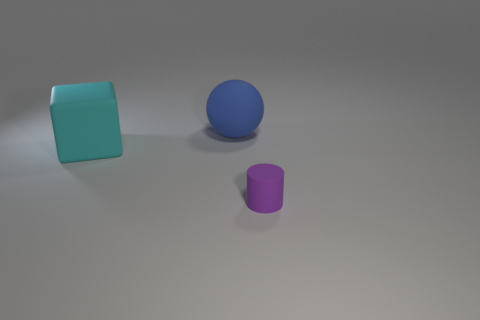Is there anything else that is the same size as the matte cylinder?
Make the answer very short. No. What number of things are either large cyan rubber things or small brown metallic cylinders?
Offer a terse response. 1. Are there the same number of objects that are to the left of the large cyan rubber object and tiny red rubber balls?
Your response must be concise. Yes. There is a rubber thing in front of the object that is to the left of the blue object; is there a cyan thing behind it?
Offer a terse response. Yes. The large sphere that is made of the same material as the purple cylinder is what color?
Ensure brevity in your answer.  Blue. What number of blocks are either small rubber things or large blue things?
Provide a succinct answer. 0. What is the size of the thing that is behind the matte thing to the left of the rubber object that is behind the rubber block?
Ensure brevity in your answer.  Large. What shape is the matte thing that is the same size as the rubber block?
Your answer should be very brief. Sphere. What is the shape of the purple thing?
Your answer should be very brief. Cylinder. Is the large thing that is in front of the ball made of the same material as the large blue sphere?
Your answer should be very brief. Yes. 